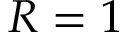Convert formula to latex. <formula><loc_0><loc_0><loc_500><loc_500>R = 1</formula> 